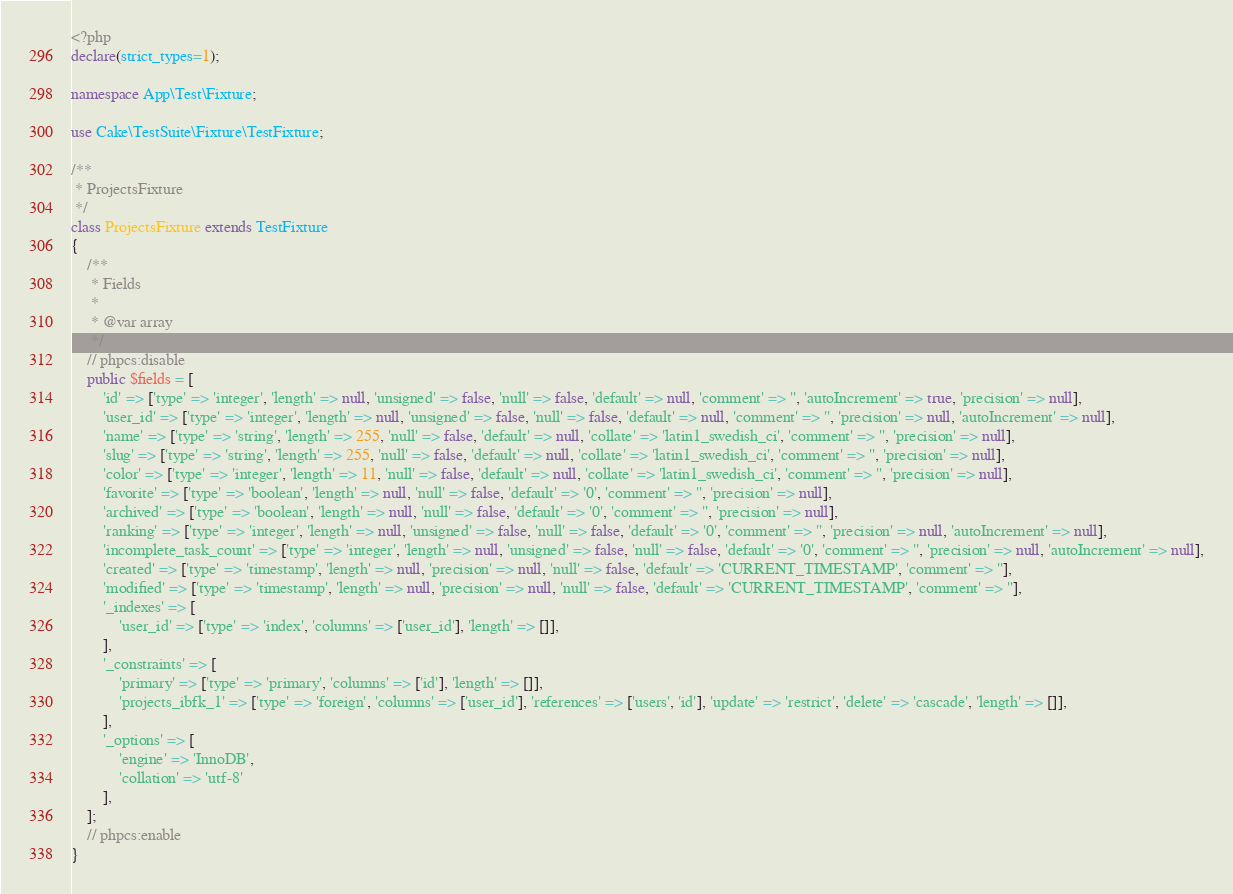Convert code to text. <code><loc_0><loc_0><loc_500><loc_500><_PHP_><?php
declare(strict_types=1);

namespace App\Test\Fixture;

use Cake\TestSuite\Fixture\TestFixture;

/**
 * ProjectsFixture
 */
class ProjectsFixture extends TestFixture
{
    /**
     * Fields
     *
     * @var array
     */
    // phpcs:disable
    public $fields = [
        'id' => ['type' => 'integer', 'length' => null, 'unsigned' => false, 'null' => false, 'default' => null, 'comment' => '', 'autoIncrement' => true, 'precision' => null],
        'user_id' => ['type' => 'integer', 'length' => null, 'unsigned' => false, 'null' => false, 'default' => null, 'comment' => '', 'precision' => null, 'autoIncrement' => null],
        'name' => ['type' => 'string', 'length' => 255, 'null' => false, 'default' => null, 'collate' => 'latin1_swedish_ci', 'comment' => '', 'precision' => null],
        'slug' => ['type' => 'string', 'length' => 255, 'null' => false, 'default' => null, 'collate' => 'latin1_swedish_ci', 'comment' => '', 'precision' => null],
        'color' => ['type' => 'integer', 'length' => 11, 'null' => false, 'default' => null, 'collate' => 'latin1_swedish_ci', 'comment' => '', 'precision' => null],
        'favorite' => ['type' => 'boolean', 'length' => null, 'null' => false, 'default' => '0', 'comment' => '', 'precision' => null],
        'archived' => ['type' => 'boolean', 'length' => null, 'null' => false, 'default' => '0', 'comment' => '', 'precision' => null],
        'ranking' => ['type' => 'integer', 'length' => null, 'unsigned' => false, 'null' => false, 'default' => '0', 'comment' => '', 'precision' => null, 'autoIncrement' => null],
        'incomplete_task_count' => ['type' => 'integer', 'length' => null, 'unsigned' => false, 'null' => false, 'default' => '0', 'comment' => '', 'precision' => null, 'autoIncrement' => null],
        'created' => ['type' => 'timestamp', 'length' => null, 'precision' => null, 'null' => false, 'default' => 'CURRENT_TIMESTAMP', 'comment' => ''],
        'modified' => ['type' => 'timestamp', 'length' => null, 'precision' => null, 'null' => false, 'default' => 'CURRENT_TIMESTAMP', 'comment' => ''],
        '_indexes' => [
            'user_id' => ['type' => 'index', 'columns' => ['user_id'], 'length' => []],
        ],
        '_constraints' => [
            'primary' => ['type' => 'primary', 'columns' => ['id'], 'length' => []],
            'projects_ibfk_1' => ['type' => 'foreign', 'columns' => ['user_id'], 'references' => ['users', 'id'], 'update' => 'restrict', 'delete' => 'cascade', 'length' => []],
        ],
        '_options' => [
            'engine' => 'InnoDB',
            'collation' => 'utf-8'
        ],
    ];
    // phpcs:enable
}
</code> 